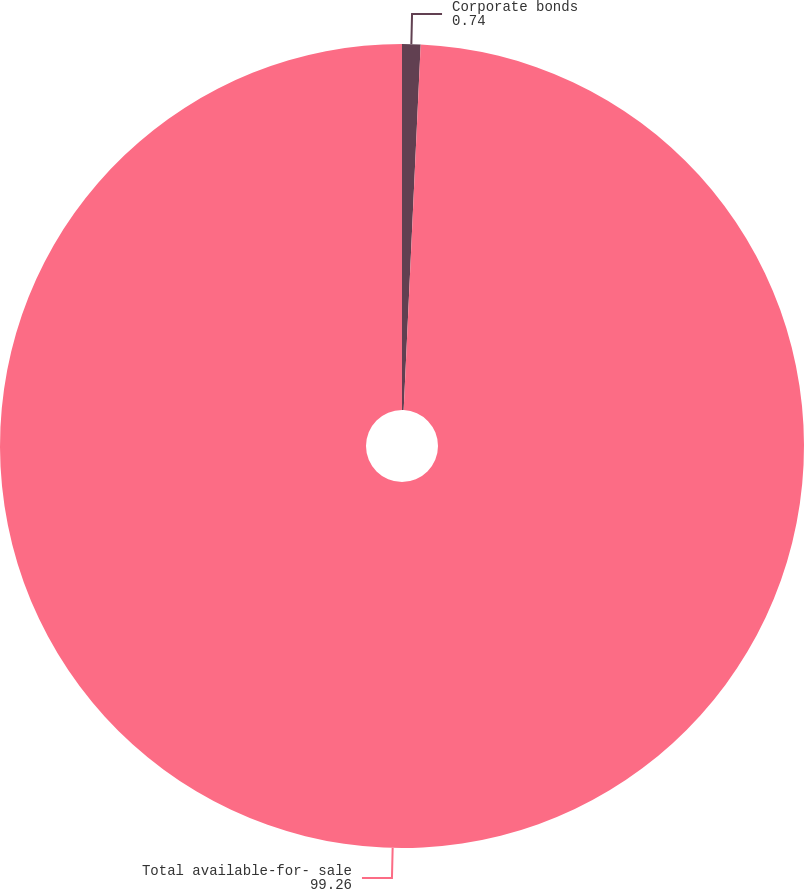<chart> <loc_0><loc_0><loc_500><loc_500><pie_chart><fcel>Corporate bonds<fcel>Total available-for- sale<nl><fcel>0.74%<fcel>99.26%<nl></chart> 